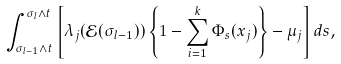Convert formula to latex. <formula><loc_0><loc_0><loc_500><loc_500>\int _ { \sigma _ { l - 1 } \wedge t } ^ { \sigma _ { l } \wedge t } \left [ \lambda _ { j } ( \mathcal { E } ( \sigma _ { l - 1 } ) ) \left \{ 1 - \sum _ { i = 1 } ^ { k } \Phi _ { s } ( x _ { j } ) \right \} - \mu _ { j } \right ] d s ,</formula> 